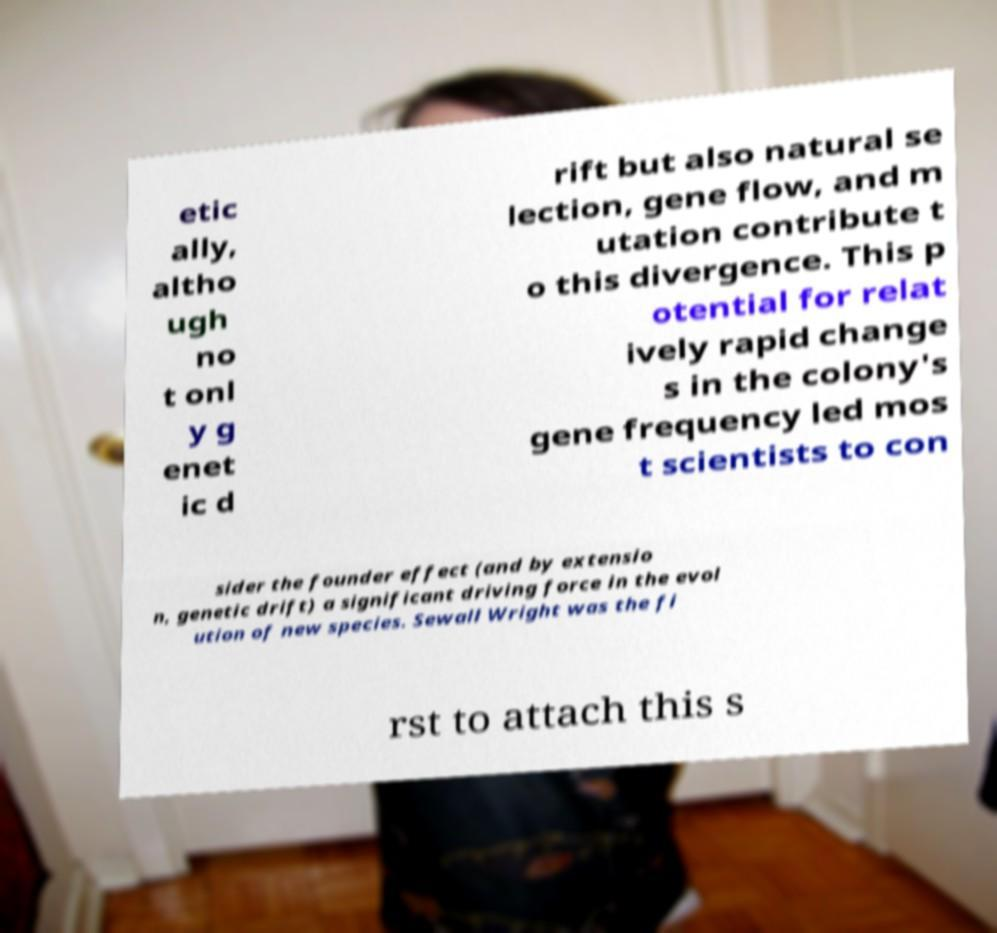Can you accurately transcribe the text from the provided image for me? etic ally, altho ugh no t onl y g enet ic d rift but also natural se lection, gene flow, and m utation contribute t o this divergence. This p otential for relat ively rapid change s in the colony's gene frequency led mos t scientists to con sider the founder effect (and by extensio n, genetic drift) a significant driving force in the evol ution of new species. Sewall Wright was the fi rst to attach this s 